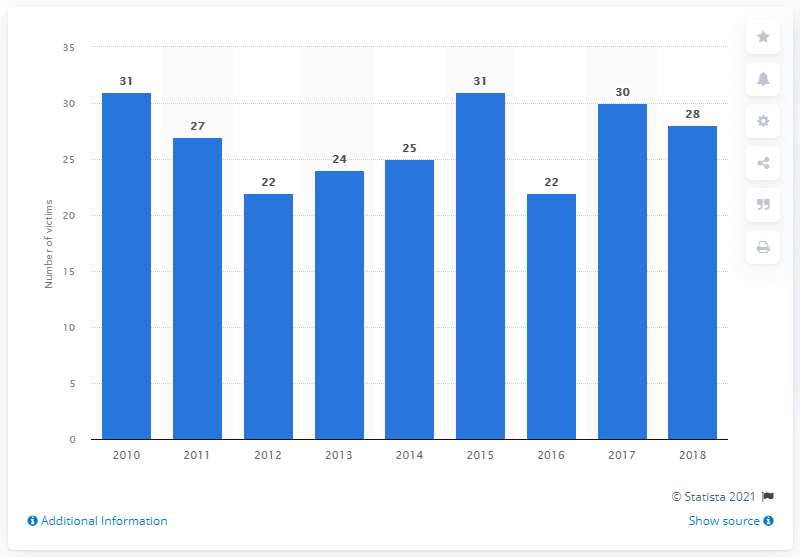Point out several critical features in this image. During the period of 2010 to 2015, a total of 31 individuals were intentionally killed in Barbados. In 2018, 28 people were murdered in Barbados. 